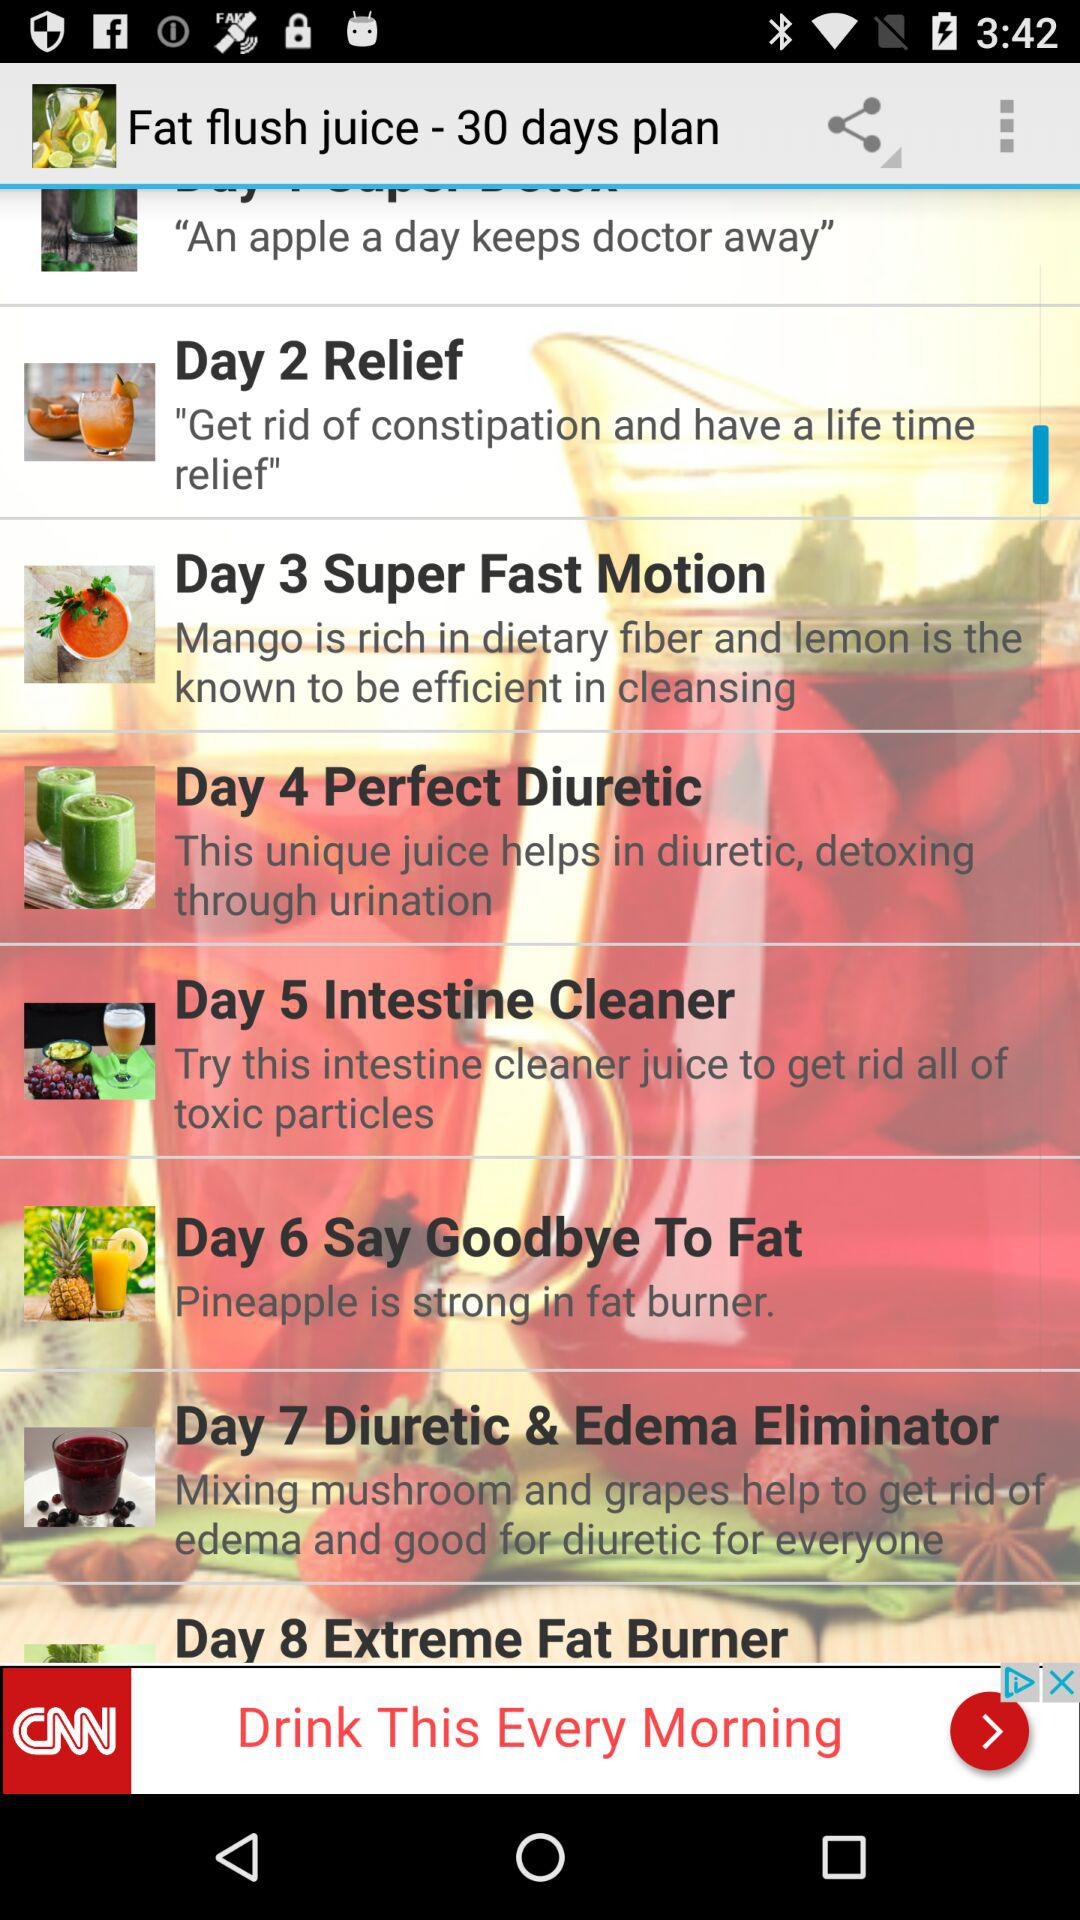Which juice do we have for day 4? The juice that you have for day 4 is "Perfect Diuretic". 